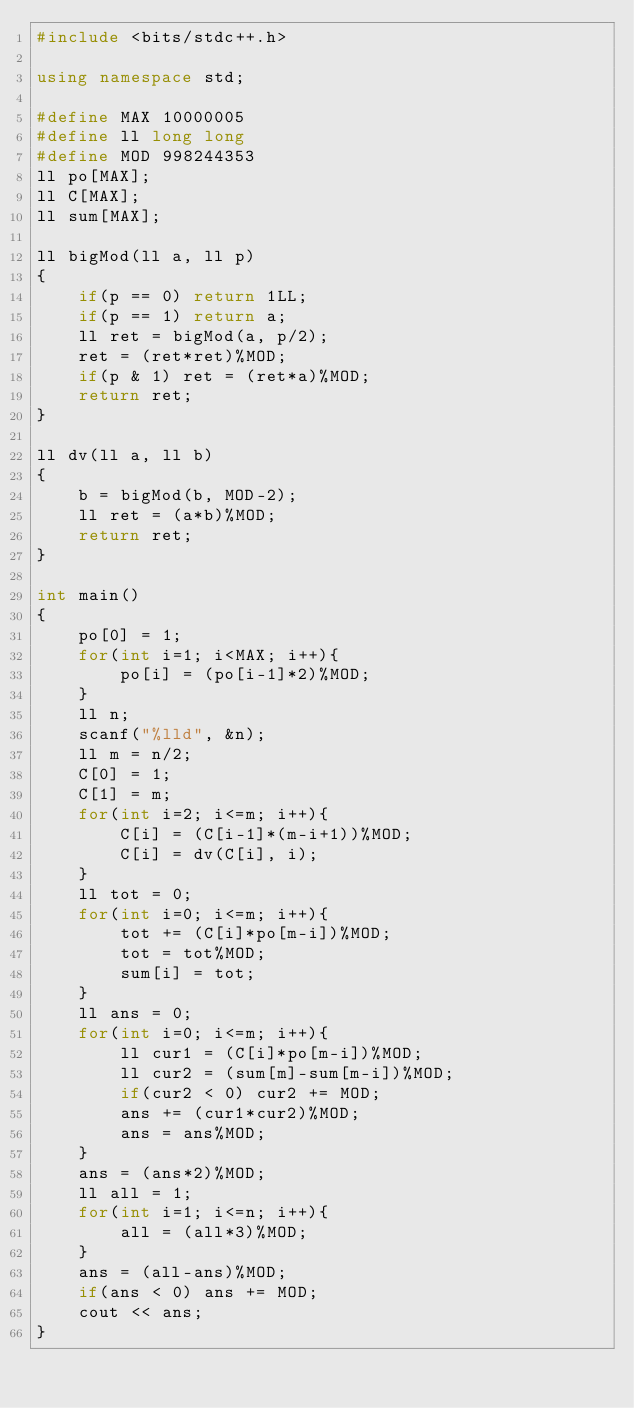Convert code to text. <code><loc_0><loc_0><loc_500><loc_500><_C++_>#include <bits/stdc++.h>

using namespace std;

#define MAX 10000005
#define ll long long
#define MOD 998244353
ll po[MAX];
ll C[MAX];
ll sum[MAX];

ll bigMod(ll a, ll p)
{
    if(p == 0) return 1LL;
    if(p == 1) return a;
    ll ret = bigMod(a, p/2);
    ret = (ret*ret)%MOD;
    if(p & 1) ret = (ret*a)%MOD;
    return ret;
}

ll dv(ll a, ll b)
{
    b = bigMod(b, MOD-2);
    ll ret = (a*b)%MOD;
    return ret;
}

int main()
{
    po[0] = 1;
    for(int i=1; i<MAX; i++){
        po[i] = (po[i-1]*2)%MOD;
    }
    ll n;
    scanf("%lld", &n);
    ll m = n/2;
    C[0] = 1;
    C[1] = m;
    for(int i=2; i<=m; i++){
        C[i] = (C[i-1]*(m-i+1))%MOD;
        C[i] = dv(C[i], i);
    }
    ll tot = 0;
    for(int i=0; i<=m; i++){
        tot += (C[i]*po[m-i])%MOD;
        tot = tot%MOD;
        sum[i] = tot;
    }
    ll ans = 0;
    for(int i=0; i<=m; i++){
        ll cur1 = (C[i]*po[m-i])%MOD;
        ll cur2 = (sum[m]-sum[m-i])%MOD;
        if(cur2 < 0) cur2 += MOD;
        ans += (cur1*cur2)%MOD;
        ans = ans%MOD;
    }
    ans = (ans*2)%MOD;
    ll all = 1;
    for(int i=1; i<=n; i++){
        all = (all*3)%MOD;
    }
    ans = (all-ans)%MOD;
    if(ans < 0) ans += MOD;
    cout << ans;
}</code> 